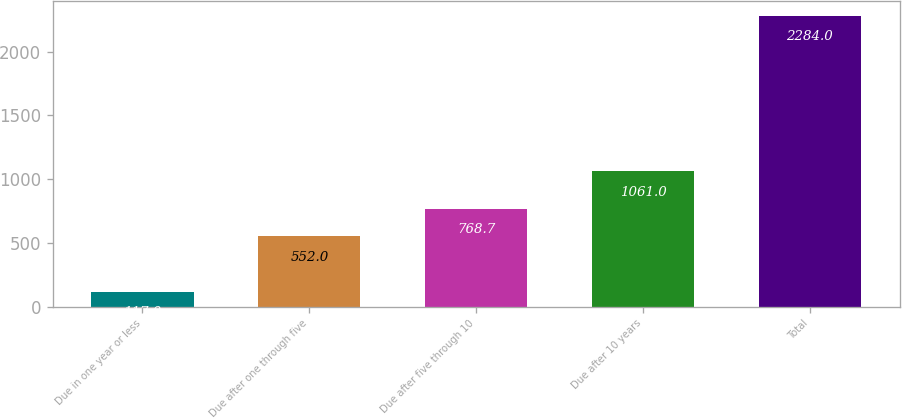Convert chart to OTSL. <chart><loc_0><loc_0><loc_500><loc_500><bar_chart><fcel>Due in one year or less<fcel>Due after one through five<fcel>Due after five through 10<fcel>Due after 10 years<fcel>Total<nl><fcel>117<fcel>552<fcel>768.7<fcel>1061<fcel>2284<nl></chart> 